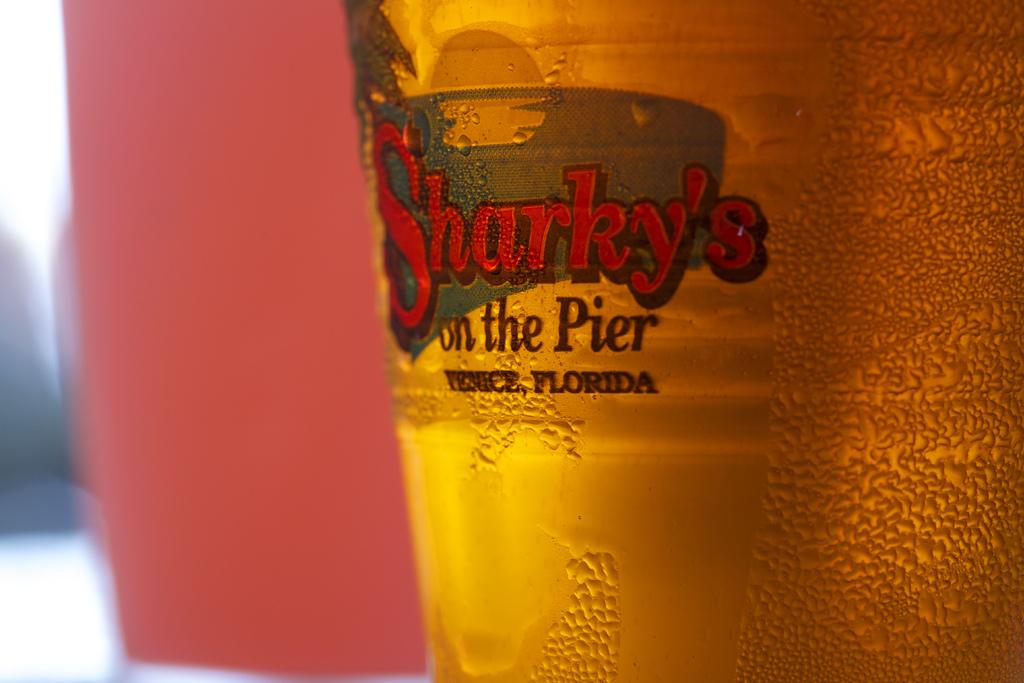What american state is is this from?
Offer a very short reply. Florida. Where is sharky's?
Give a very brief answer. Venice, florida. 